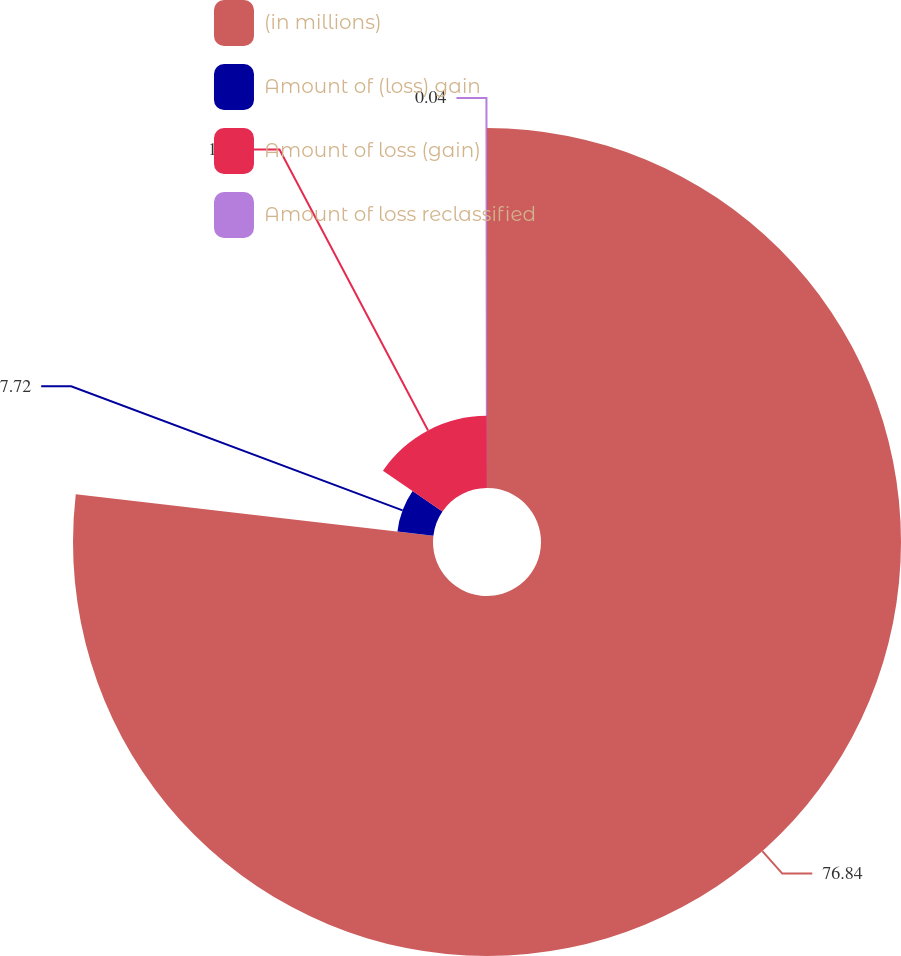Convert chart. <chart><loc_0><loc_0><loc_500><loc_500><pie_chart><fcel>(in millions)<fcel>Amount of (loss) gain<fcel>Amount of loss (gain)<fcel>Amount of loss reclassified<nl><fcel>76.84%<fcel>7.72%<fcel>15.4%<fcel>0.04%<nl></chart> 